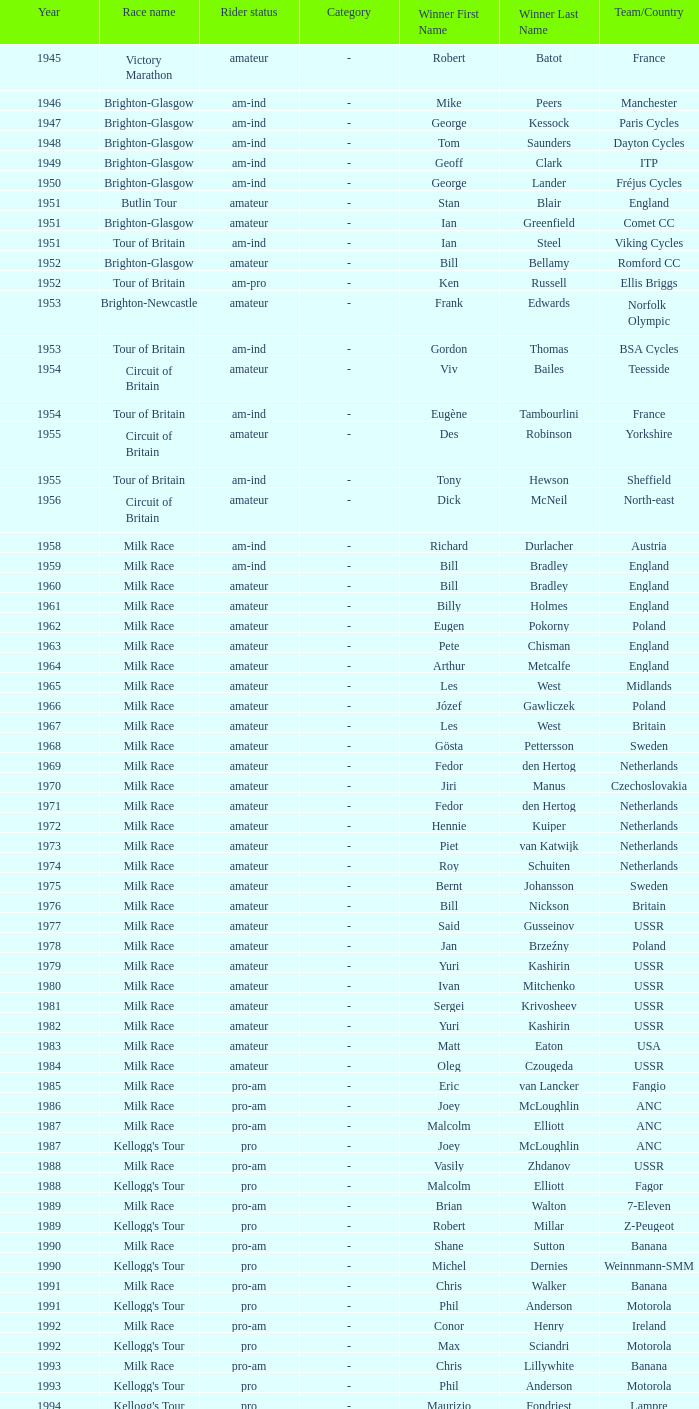In the kellogg's tour, which team played beyond 1958? ANC, Fagor, Z-Peugeot, Weinnmann-SMM, Motorola, Motorola, Motorola, Lampre. 